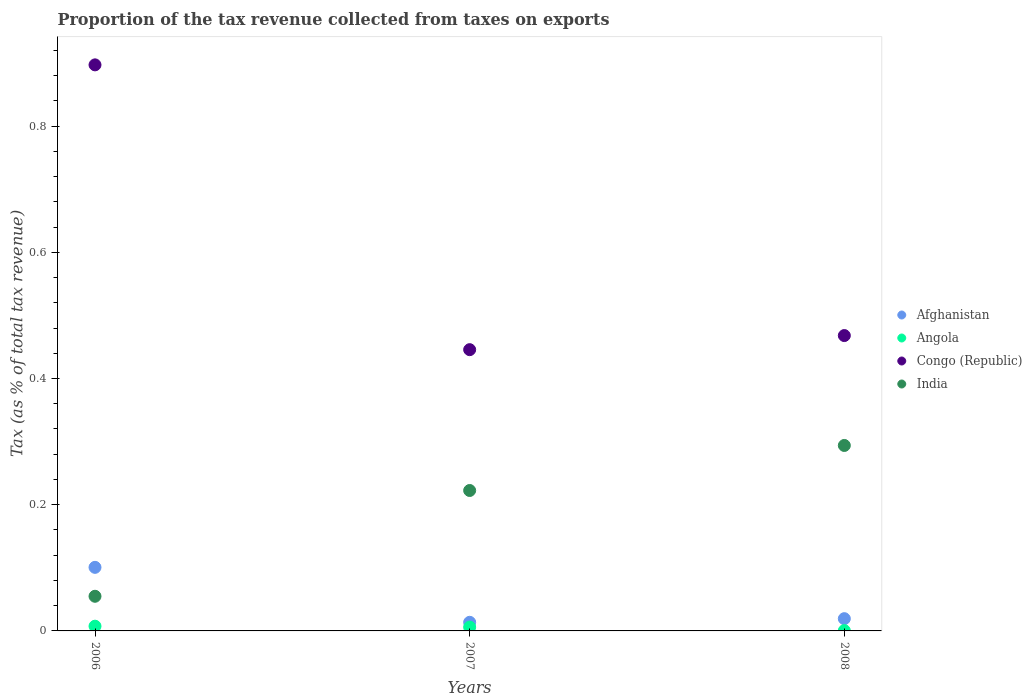How many different coloured dotlines are there?
Make the answer very short. 4. Is the number of dotlines equal to the number of legend labels?
Provide a succinct answer. Yes. What is the proportion of the tax revenue collected in Angola in 2006?
Your answer should be very brief. 0.01. Across all years, what is the maximum proportion of the tax revenue collected in India?
Your answer should be very brief. 0.29. Across all years, what is the minimum proportion of the tax revenue collected in Afghanistan?
Offer a terse response. 0.01. In which year was the proportion of the tax revenue collected in Congo (Republic) minimum?
Keep it short and to the point. 2007. What is the total proportion of the tax revenue collected in Angola in the graph?
Your answer should be very brief. 0.01. What is the difference between the proportion of the tax revenue collected in Angola in 2006 and that in 2008?
Your response must be concise. 0.01. What is the difference between the proportion of the tax revenue collected in Angola in 2006 and the proportion of the tax revenue collected in India in 2007?
Keep it short and to the point. -0.22. What is the average proportion of the tax revenue collected in Congo (Republic) per year?
Provide a short and direct response. 0.6. In the year 2006, what is the difference between the proportion of the tax revenue collected in Congo (Republic) and proportion of the tax revenue collected in India?
Provide a succinct answer. 0.84. What is the ratio of the proportion of the tax revenue collected in Afghanistan in 2006 to that in 2007?
Give a very brief answer. 7.37. Is the difference between the proportion of the tax revenue collected in Congo (Republic) in 2006 and 2007 greater than the difference between the proportion of the tax revenue collected in India in 2006 and 2007?
Your answer should be very brief. Yes. What is the difference between the highest and the second highest proportion of the tax revenue collected in Afghanistan?
Ensure brevity in your answer.  0.08. What is the difference between the highest and the lowest proportion of the tax revenue collected in Angola?
Your response must be concise. 0.01. In how many years, is the proportion of the tax revenue collected in India greater than the average proportion of the tax revenue collected in India taken over all years?
Your response must be concise. 2. Is the sum of the proportion of the tax revenue collected in Congo (Republic) in 2006 and 2008 greater than the maximum proportion of the tax revenue collected in Afghanistan across all years?
Keep it short and to the point. Yes. Is it the case that in every year, the sum of the proportion of the tax revenue collected in Angola and proportion of the tax revenue collected in India  is greater than the sum of proportion of the tax revenue collected in Afghanistan and proportion of the tax revenue collected in Congo (Republic)?
Your answer should be very brief. No. Does the proportion of the tax revenue collected in India monotonically increase over the years?
Offer a very short reply. Yes. How many dotlines are there?
Give a very brief answer. 4. How many legend labels are there?
Give a very brief answer. 4. What is the title of the graph?
Your answer should be very brief. Proportion of the tax revenue collected from taxes on exports. Does "Barbados" appear as one of the legend labels in the graph?
Give a very brief answer. No. What is the label or title of the Y-axis?
Offer a terse response. Tax (as % of total tax revenue). What is the Tax (as % of total tax revenue) of Afghanistan in 2006?
Give a very brief answer. 0.1. What is the Tax (as % of total tax revenue) of Angola in 2006?
Your answer should be very brief. 0.01. What is the Tax (as % of total tax revenue) of Congo (Republic) in 2006?
Offer a very short reply. 0.9. What is the Tax (as % of total tax revenue) in India in 2006?
Make the answer very short. 0.05. What is the Tax (as % of total tax revenue) in Afghanistan in 2007?
Your answer should be very brief. 0.01. What is the Tax (as % of total tax revenue) of Angola in 2007?
Give a very brief answer. 0.01. What is the Tax (as % of total tax revenue) in Congo (Republic) in 2007?
Ensure brevity in your answer.  0.45. What is the Tax (as % of total tax revenue) of India in 2007?
Provide a short and direct response. 0.22. What is the Tax (as % of total tax revenue) in Afghanistan in 2008?
Your answer should be compact. 0.02. What is the Tax (as % of total tax revenue) of Angola in 2008?
Offer a terse response. 0. What is the Tax (as % of total tax revenue) of Congo (Republic) in 2008?
Make the answer very short. 0.47. What is the Tax (as % of total tax revenue) in India in 2008?
Give a very brief answer. 0.29. Across all years, what is the maximum Tax (as % of total tax revenue) of Afghanistan?
Your answer should be very brief. 0.1. Across all years, what is the maximum Tax (as % of total tax revenue) in Angola?
Your answer should be compact. 0.01. Across all years, what is the maximum Tax (as % of total tax revenue) of Congo (Republic)?
Give a very brief answer. 0.9. Across all years, what is the maximum Tax (as % of total tax revenue) of India?
Offer a terse response. 0.29. Across all years, what is the minimum Tax (as % of total tax revenue) of Afghanistan?
Keep it short and to the point. 0.01. Across all years, what is the minimum Tax (as % of total tax revenue) in Angola?
Your answer should be compact. 0. Across all years, what is the minimum Tax (as % of total tax revenue) of Congo (Republic)?
Your response must be concise. 0.45. Across all years, what is the minimum Tax (as % of total tax revenue) in India?
Ensure brevity in your answer.  0.05. What is the total Tax (as % of total tax revenue) of Afghanistan in the graph?
Your response must be concise. 0.13. What is the total Tax (as % of total tax revenue) of Angola in the graph?
Your answer should be very brief. 0.01. What is the total Tax (as % of total tax revenue) in Congo (Republic) in the graph?
Your response must be concise. 1.81. What is the total Tax (as % of total tax revenue) of India in the graph?
Make the answer very short. 0.57. What is the difference between the Tax (as % of total tax revenue) of Afghanistan in 2006 and that in 2007?
Make the answer very short. 0.09. What is the difference between the Tax (as % of total tax revenue) in Angola in 2006 and that in 2007?
Your answer should be very brief. 0. What is the difference between the Tax (as % of total tax revenue) of Congo (Republic) in 2006 and that in 2007?
Ensure brevity in your answer.  0.45. What is the difference between the Tax (as % of total tax revenue) of India in 2006 and that in 2007?
Offer a very short reply. -0.17. What is the difference between the Tax (as % of total tax revenue) of Afghanistan in 2006 and that in 2008?
Your response must be concise. 0.08. What is the difference between the Tax (as % of total tax revenue) in Angola in 2006 and that in 2008?
Offer a terse response. 0.01. What is the difference between the Tax (as % of total tax revenue) of Congo (Republic) in 2006 and that in 2008?
Your answer should be very brief. 0.43. What is the difference between the Tax (as % of total tax revenue) of India in 2006 and that in 2008?
Offer a very short reply. -0.24. What is the difference between the Tax (as % of total tax revenue) of Afghanistan in 2007 and that in 2008?
Provide a short and direct response. -0.01. What is the difference between the Tax (as % of total tax revenue) of Angola in 2007 and that in 2008?
Make the answer very short. 0.01. What is the difference between the Tax (as % of total tax revenue) of Congo (Republic) in 2007 and that in 2008?
Your response must be concise. -0.02. What is the difference between the Tax (as % of total tax revenue) in India in 2007 and that in 2008?
Your answer should be very brief. -0.07. What is the difference between the Tax (as % of total tax revenue) of Afghanistan in 2006 and the Tax (as % of total tax revenue) of Angola in 2007?
Your response must be concise. 0.09. What is the difference between the Tax (as % of total tax revenue) in Afghanistan in 2006 and the Tax (as % of total tax revenue) in Congo (Republic) in 2007?
Your answer should be compact. -0.34. What is the difference between the Tax (as % of total tax revenue) of Afghanistan in 2006 and the Tax (as % of total tax revenue) of India in 2007?
Give a very brief answer. -0.12. What is the difference between the Tax (as % of total tax revenue) of Angola in 2006 and the Tax (as % of total tax revenue) of Congo (Republic) in 2007?
Provide a short and direct response. -0.44. What is the difference between the Tax (as % of total tax revenue) in Angola in 2006 and the Tax (as % of total tax revenue) in India in 2007?
Offer a terse response. -0.21. What is the difference between the Tax (as % of total tax revenue) of Congo (Republic) in 2006 and the Tax (as % of total tax revenue) of India in 2007?
Ensure brevity in your answer.  0.67. What is the difference between the Tax (as % of total tax revenue) in Afghanistan in 2006 and the Tax (as % of total tax revenue) in Angola in 2008?
Provide a short and direct response. 0.1. What is the difference between the Tax (as % of total tax revenue) of Afghanistan in 2006 and the Tax (as % of total tax revenue) of Congo (Republic) in 2008?
Your response must be concise. -0.37. What is the difference between the Tax (as % of total tax revenue) of Afghanistan in 2006 and the Tax (as % of total tax revenue) of India in 2008?
Your answer should be compact. -0.19. What is the difference between the Tax (as % of total tax revenue) of Angola in 2006 and the Tax (as % of total tax revenue) of Congo (Republic) in 2008?
Provide a short and direct response. -0.46. What is the difference between the Tax (as % of total tax revenue) of Angola in 2006 and the Tax (as % of total tax revenue) of India in 2008?
Your response must be concise. -0.29. What is the difference between the Tax (as % of total tax revenue) in Congo (Republic) in 2006 and the Tax (as % of total tax revenue) in India in 2008?
Offer a terse response. 0.6. What is the difference between the Tax (as % of total tax revenue) in Afghanistan in 2007 and the Tax (as % of total tax revenue) in Angola in 2008?
Offer a terse response. 0.01. What is the difference between the Tax (as % of total tax revenue) of Afghanistan in 2007 and the Tax (as % of total tax revenue) of Congo (Republic) in 2008?
Your response must be concise. -0.45. What is the difference between the Tax (as % of total tax revenue) of Afghanistan in 2007 and the Tax (as % of total tax revenue) of India in 2008?
Provide a succinct answer. -0.28. What is the difference between the Tax (as % of total tax revenue) in Angola in 2007 and the Tax (as % of total tax revenue) in Congo (Republic) in 2008?
Provide a succinct answer. -0.46. What is the difference between the Tax (as % of total tax revenue) of Angola in 2007 and the Tax (as % of total tax revenue) of India in 2008?
Your answer should be very brief. -0.29. What is the difference between the Tax (as % of total tax revenue) of Congo (Republic) in 2007 and the Tax (as % of total tax revenue) of India in 2008?
Keep it short and to the point. 0.15. What is the average Tax (as % of total tax revenue) of Afghanistan per year?
Make the answer very short. 0.04. What is the average Tax (as % of total tax revenue) in Angola per year?
Your answer should be very brief. 0. What is the average Tax (as % of total tax revenue) in Congo (Republic) per year?
Offer a very short reply. 0.6. What is the average Tax (as % of total tax revenue) in India per year?
Provide a short and direct response. 0.19. In the year 2006, what is the difference between the Tax (as % of total tax revenue) in Afghanistan and Tax (as % of total tax revenue) in Angola?
Keep it short and to the point. 0.09. In the year 2006, what is the difference between the Tax (as % of total tax revenue) in Afghanistan and Tax (as % of total tax revenue) in Congo (Republic)?
Your answer should be very brief. -0.8. In the year 2006, what is the difference between the Tax (as % of total tax revenue) of Afghanistan and Tax (as % of total tax revenue) of India?
Offer a terse response. 0.05. In the year 2006, what is the difference between the Tax (as % of total tax revenue) in Angola and Tax (as % of total tax revenue) in Congo (Republic)?
Offer a very short reply. -0.89. In the year 2006, what is the difference between the Tax (as % of total tax revenue) of Angola and Tax (as % of total tax revenue) of India?
Ensure brevity in your answer.  -0.05. In the year 2006, what is the difference between the Tax (as % of total tax revenue) in Congo (Republic) and Tax (as % of total tax revenue) in India?
Ensure brevity in your answer.  0.84. In the year 2007, what is the difference between the Tax (as % of total tax revenue) of Afghanistan and Tax (as % of total tax revenue) of Angola?
Offer a very short reply. 0.01. In the year 2007, what is the difference between the Tax (as % of total tax revenue) in Afghanistan and Tax (as % of total tax revenue) in Congo (Republic)?
Offer a very short reply. -0.43. In the year 2007, what is the difference between the Tax (as % of total tax revenue) of Afghanistan and Tax (as % of total tax revenue) of India?
Make the answer very short. -0.21. In the year 2007, what is the difference between the Tax (as % of total tax revenue) of Angola and Tax (as % of total tax revenue) of Congo (Republic)?
Offer a terse response. -0.44. In the year 2007, what is the difference between the Tax (as % of total tax revenue) of Angola and Tax (as % of total tax revenue) of India?
Keep it short and to the point. -0.22. In the year 2007, what is the difference between the Tax (as % of total tax revenue) of Congo (Republic) and Tax (as % of total tax revenue) of India?
Make the answer very short. 0.22. In the year 2008, what is the difference between the Tax (as % of total tax revenue) in Afghanistan and Tax (as % of total tax revenue) in Angola?
Your answer should be compact. 0.02. In the year 2008, what is the difference between the Tax (as % of total tax revenue) of Afghanistan and Tax (as % of total tax revenue) of Congo (Republic)?
Provide a succinct answer. -0.45. In the year 2008, what is the difference between the Tax (as % of total tax revenue) in Afghanistan and Tax (as % of total tax revenue) in India?
Offer a terse response. -0.27. In the year 2008, what is the difference between the Tax (as % of total tax revenue) of Angola and Tax (as % of total tax revenue) of Congo (Republic)?
Ensure brevity in your answer.  -0.47. In the year 2008, what is the difference between the Tax (as % of total tax revenue) of Angola and Tax (as % of total tax revenue) of India?
Make the answer very short. -0.29. In the year 2008, what is the difference between the Tax (as % of total tax revenue) of Congo (Republic) and Tax (as % of total tax revenue) of India?
Give a very brief answer. 0.17. What is the ratio of the Tax (as % of total tax revenue) of Afghanistan in 2006 to that in 2007?
Give a very brief answer. 7.37. What is the ratio of the Tax (as % of total tax revenue) of Angola in 2006 to that in 2007?
Provide a succinct answer. 1.25. What is the ratio of the Tax (as % of total tax revenue) in Congo (Republic) in 2006 to that in 2007?
Provide a succinct answer. 2.01. What is the ratio of the Tax (as % of total tax revenue) in India in 2006 to that in 2007?
Offer a very short reply. 0.25. What is the ratio of the Tax (as % of total tax revenue) in Afghanistan in 2006 to that in 2008?
Offer a very short reply. 5.19. What is the ratio of the Tax (as % of total tax revenue) in Angola in 2006 to that in 2008?
Your answer should be compact. 14.83. What is the ratio of the Tax (as % of total tax revenue) of Congo (Republic) in 2006 to that in 2008?
Make the answer very short. 1.92. What is the ratio of the Tax (as % of total tax revenue) of India in 2006 to that in 2008?
Your response must be concise. 0.19. What is the ratio of the Tax (as % of total tax revenue) in Afghanistan in 2007 to that in 2008?
Offer a very short reply. 0.7. What is the ratio of the Tax (as % of total tax revenue) of Angola in 2007 to that in 2008?
Your answer should be very brief. 11.89. What is the ratio of the Tax (as % of total tax revenue) of Congo (Republic) in 2007 to that in 2008?
Make the answer very short. 0.95. What is the ratio of the Tax (as % of total tax revenue) in India in 2007 to that in 2008?
Your response must be concise. 0.76. What is the difference between the highest and the second highest Tax (as % of total tax revenue) of Afghanistan?
Give a very brief answer. 0.08. What is the difference between the highest and the second highest Tax (as % of total tax revenue) of Angola?
Offer a terse response. 0. What is the difference between the highest and the second highest Tax (as % of total tax revenue) in Congo (Republic)?
Your answer should be very brief. 0.43. What is the difference between the highest and the second highest Tax (as % of total tax revenue) in India?
Keep it short and to the point. 0.07. What is the difference between the highest and the lowest Tax (as % of total tax revenue) in Afghanistan?
Ensure brevity in your answer.  0.09. What is the difference between the highest and the lowest Tax (as % of total tax revenue) in Angola?
Provide a succinct answer. 0.01. What is the difference between the highest and the lowest Tax (as % of total tax revenue) of Congo (Republic)?
Your answer should be compact. 0.45. What is the difference between the highest and the lowest Tax (as % of total tax revenue) of India?
Provide a succinct answer. 0.24. 